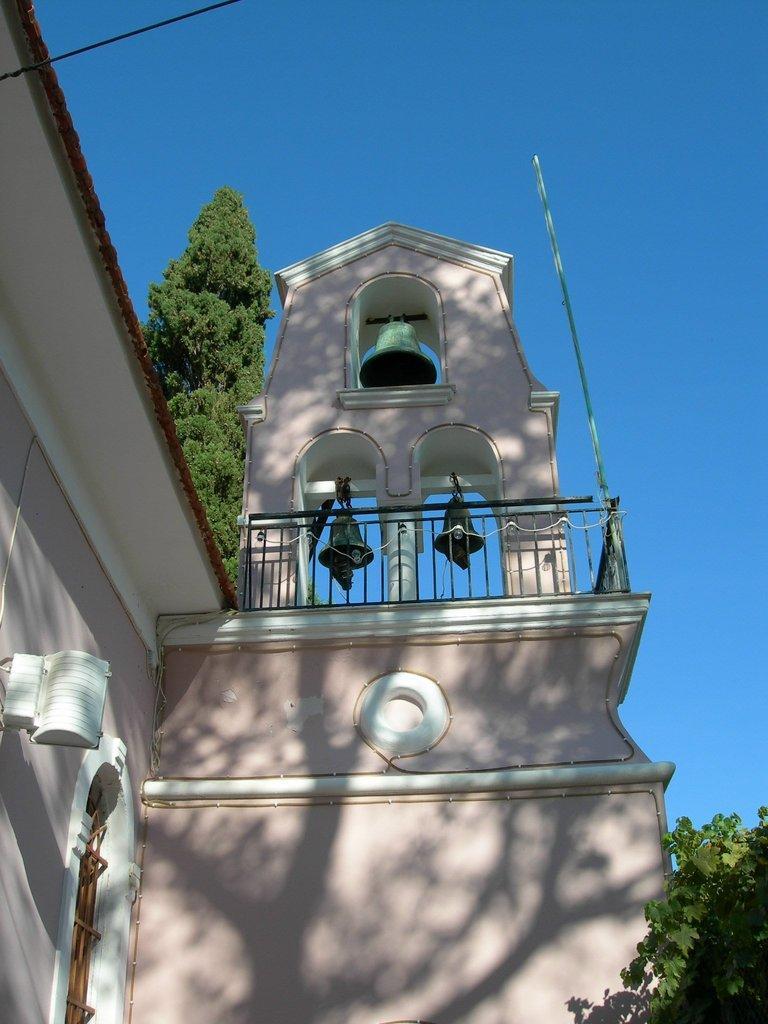Could you give a brief overview of what you see in this image? In this image there is the sky towards the top of the image, there are trees, there are bells, there is a rod, there is a wall towards the bottom of the image, there are lights on the wall, there is a wire towards the top of the image. 